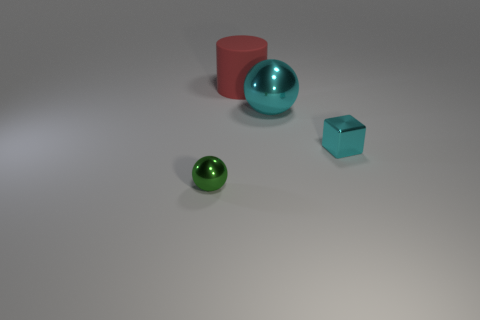Add 1 blue metal cylinders. How many objects exist? 5 Subtract all cylinders. How many objects are left? 3 Subtract 0 brown cubes. How many objects are left? 4 Subtract all blue metallic cylinders. Subtract all red matte cylinders. How many objects are left? 3 Add 1 green metal objects. How many green metal objects are left? 2 Add 4 red rubber objects. How many red rubber objects exist? 5 